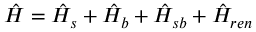<formula> <loc_0><loc_0><loc_500><loc_500>\hat { H } = \hat { H } _ { s } + \hat { H } _ { b } + \hat { H } _ { s b } + \hat { H } _ { r e n }</formula> 